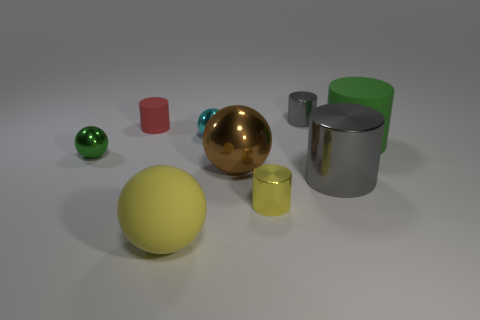Subtract all red cylinders. How many cylinders are left? 4 Subtract all green cylinders. How many cylinders are left? 4 Subtract all purple cylinders. Subtract all blue spheres. How many cylinders are left? 5 Add 1 small cyan things. How many objects exist? 10 Subtract all cylinders. How many objects are left? 4 Subtract all red metallic balls. Subtract all large brown objects. How many objects are left? 8 Add 3 tiny shiny objects. How many tiny shiny objects are left? 7 Add 8 brown balls. How many brown balls exist? 9 Subtract 1 green balls. How many objects are left? 8 